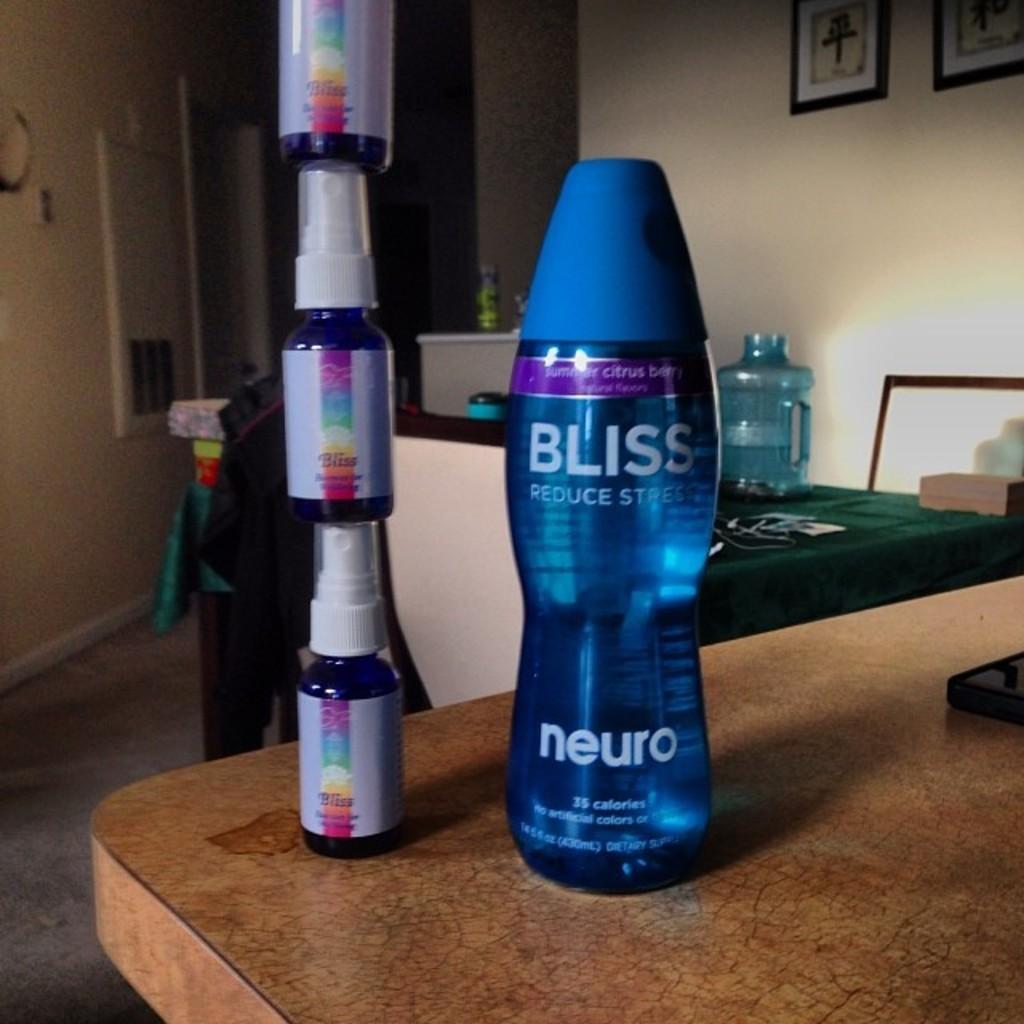What is the name of the product on the right?
Offer a very short reply. Bliss. What is the brand of the bottle on the right?
Provide a succinct answer. Bliss. 